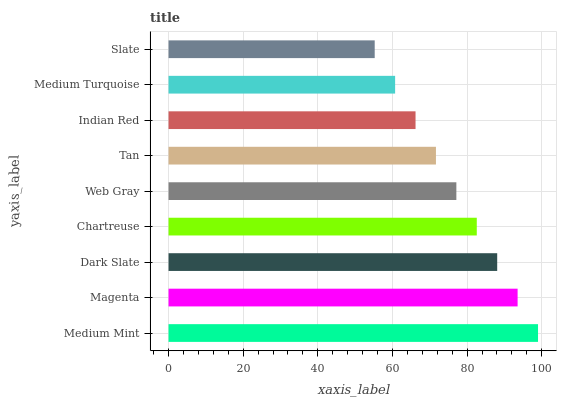Is Slate the minimum?
Answer yes or no. Yes. Is Medium Mint the maximum?
Answer yes or no. Yes. Is Magenta the minimum?
Answer yes or no. No. Is Magenta the maximum?
Answer yes or no. No. Is Medium Mint greater than Magenta?
Answer yes or no. Yes. Is Magenta less than Medium Mint?
Answer yes or no. Yes. Is Magenta greater than Medium Mint?
Answer yes or no. No. Is Medium Mint less than Magenta?
Answer yes or no. No. Is Web Gray the high median?
Answer yes or no. Yes. Is Web Gray the low median?
Answer yes or no. Yes. Is Magenta the high median?
Answer yes or no. No. Is Indian Red the low median?
Answer yes or no. No. 